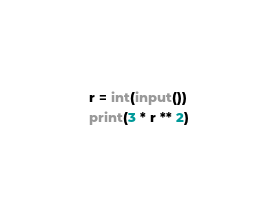Convert code to text. <code><loc_0><loc_0><loc_500><loc_500><_Python_>r = int(input())
print(3 * r ** 2)</code> 